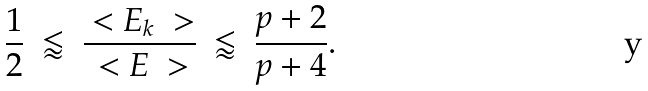Convert formula to latex. <formula><loc_0><loc_0><loc_500><loc_500>\frac { 1 } { 2 } \ \lessapprox \ \frac { \ < E _ { k } \ > } { \ < E \ > } \ \lessapprox \ \frac { p + 2 } { p + 4 } .</formula> 